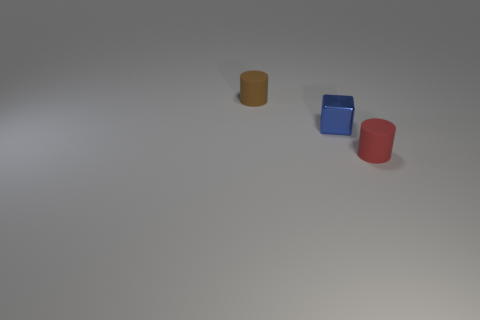The object that is in front of the brown thing and behind the red rubber object is what color? blue 